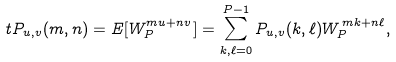Convert formula to latex. <formula><loc_0><loc_0><loc_500><loc_500>\ t P _ { u , v } ( m , n ) = E [ W _ { P } ^ { m u + n v } ] = \sum _ { k , \ell = 0 } ^ { P - 1 } P _ { u , v } ( k , \ell ) W _ { P } ^ { \, m k + n \ell } ,</formula> 